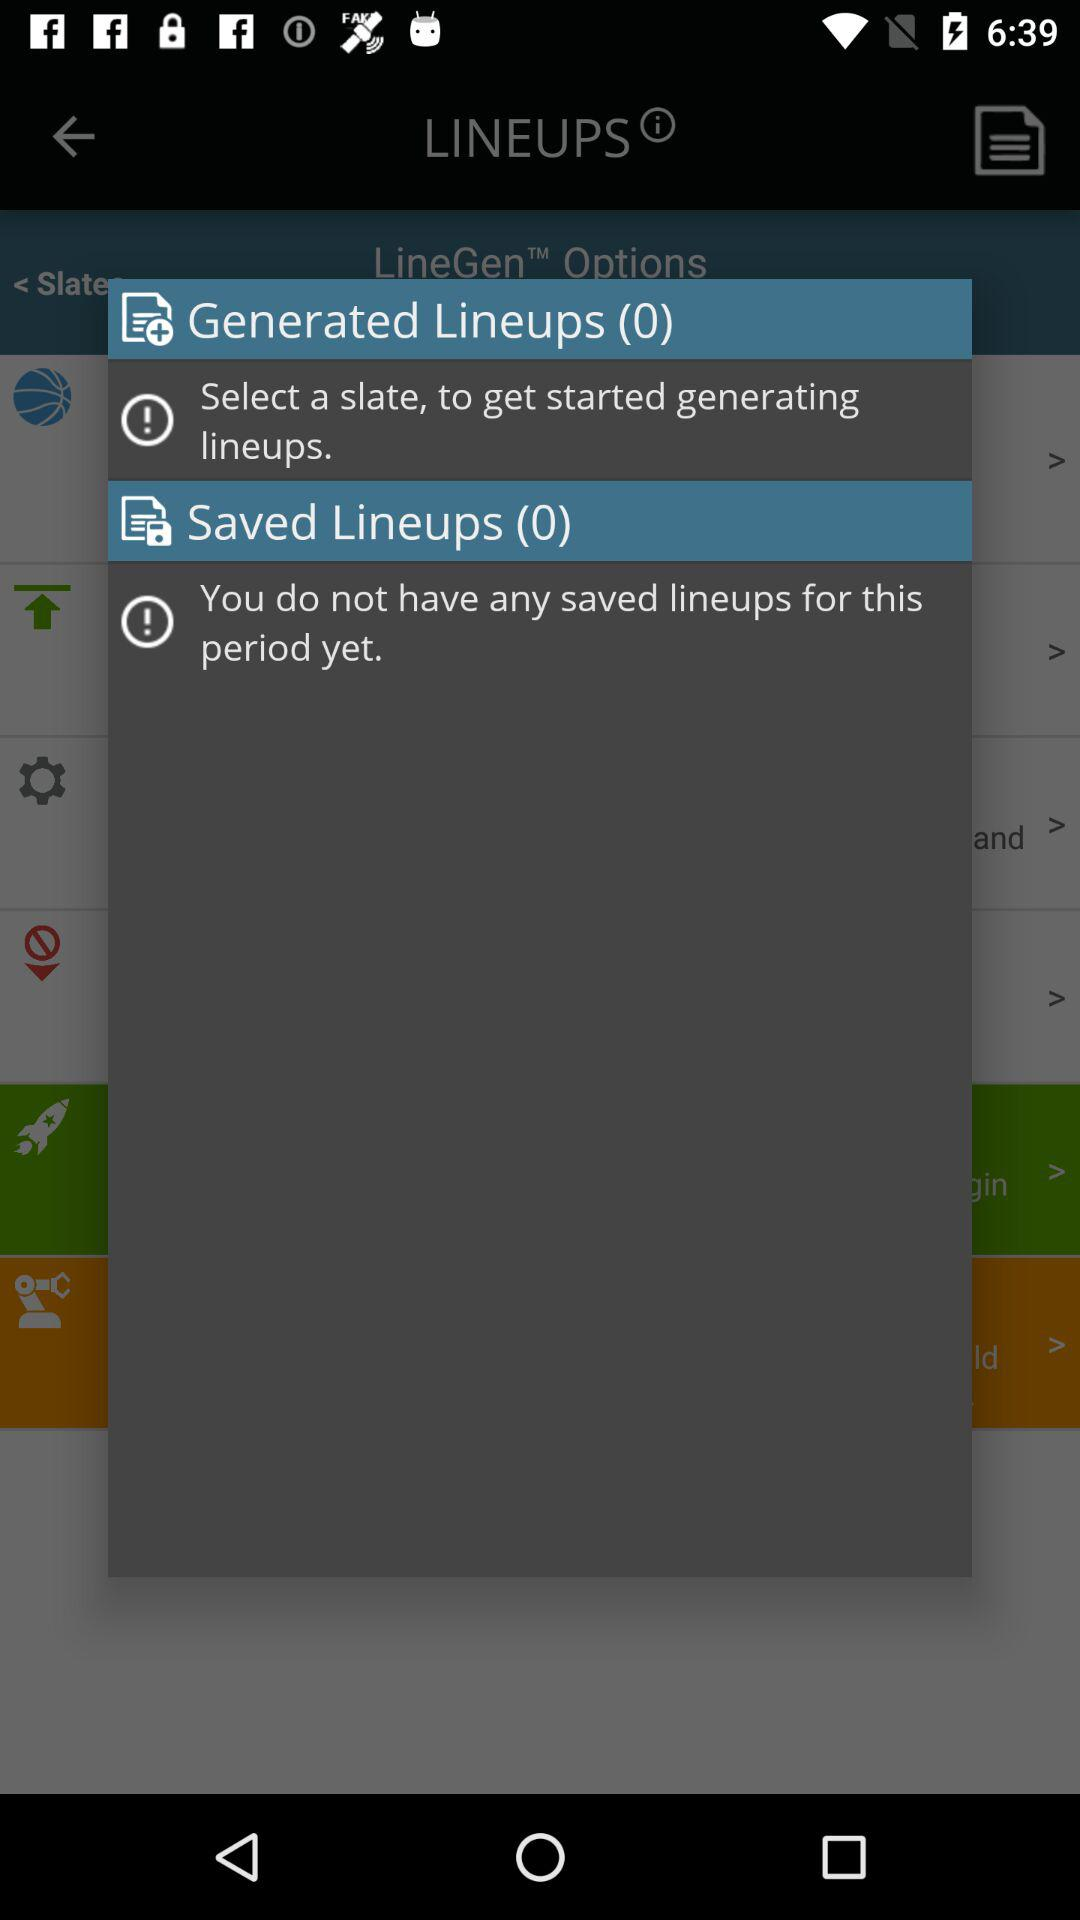What's the total number of saved lineups? The total number of saved lineups is 0. 